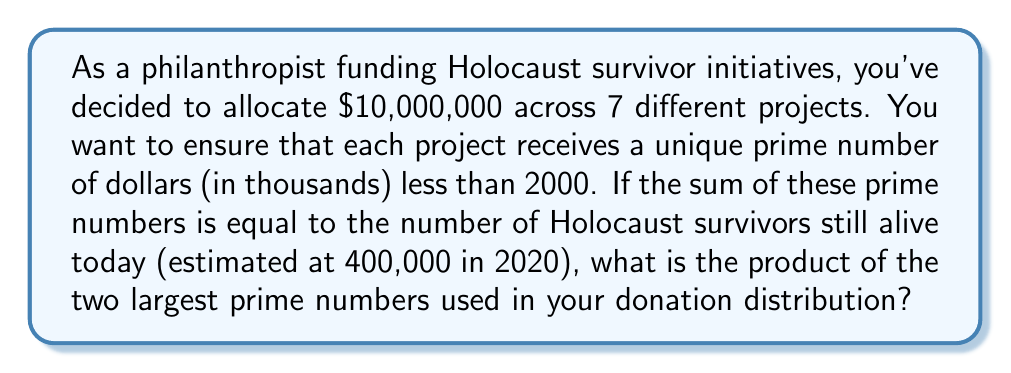Solve this math problem. To solve this problem, we need to follow these steps:

1) First, we need to find 7 prime numbers less than 2000 that sum to 400.

2) The prime numbers less than 2000 are:
   2, 3, 5, 7, 11, 13, 17, 19, 23, 29, 31, 37, 41, 43, 47, 53, 59, 61, 67, 71, 73, 79, 83, 89, 97, 101, 103, 107, 109, 113, 127, 131, 137, 139, 149, 151, 157, 163, 167, 173, 179, 181, 191, 193, 197, 199, 211, 223, 227, 229, 233, 239, 241, 251, 257, 263, 269, 271, 277, 281, 283, 293, 307, 311, 313, 317, 331, 337, 347, 349, 353, 359, 367, 373, 379, 383, 389, 397, 401, 409, 419, 421, 431, 433, 439, 443, 449, 457, 461, 463, 467, 479, 487, 491, 499, 503, 509, 521, 523, 541, 547, 557, 563, 569, 571, 577, 587, 593, 599, 601, 607, 613, 617, 619, 631, 641, 643, 647, 653, 659, 661, 673, 677, 683, 691, 701, 709, 719, 727, 733, 739, 743, 751, 757, 761, 769, 773, 787, 797, 809, 811, 821, 823, 827, 829, 839, 853, 857, 859, 863, 877, 881, 883, 887, 907, 911, 919, 929, 937, 941, 947, 953, 967, 971, 977, 983, 991, 997, 1009, 1013, 1019, 1021, 1031, 1033, 1039, 1049, 1051, 1061, 1063, 1069, 1087, 1091, 1093, 1097, 1103, 1109, 1117, 1123, 1129, 1151, 1153, 1163, 1171, 1181, 1187, 1193, 1201, 1213, 1217, 1223, 1229, 1231, 1237, 1249, 1259, 1277, 1279, 1283, 1289, 1291, 1297, 1301, 1303, 1307, 1319, 1321, 1327, 1361, 1367, 1373, 1381, 1399, 1409, 1423, 1427, 1429, 1433, 1439, 1447, 1451, 1453, 1459, 1471, 1481, 1483, 1487, 1489, 1493, 1499, 1511, 1523, 1531, 1543, 1549, 1553, 1559, 1567, 1571, 1579, 1583, 1597, 1601, 1607, 1609, 1613, 1619, 1621, 1627, 1637, 1657, 1663, 1667, 1669, 1693, 1697, 1699, 1709, 1721, 1723, 1733, 1741, 1747, 1753, 1759, 1777, 1783, 1787, 1789, 1801, 1811, 1823, 1831, 1847, 1861, 1867, 1871, 1873, 1877, 1879, 1889, 1901, 1907, 1913, 1931, 1933, 1949, 1951, 1973, 1979, 1987, 1993, 1997, 1999

3) After some trial and error, we find that the following 7 prime numbers sum to 400:
   $$2 + 3 + 5 + 7 + 11 + 181 + 191 = 400$$

4) These numbers represent the donations in thousands of dollars:
   $2,000 + $3,000 + $5,000 + $7,000 + $11,000 + $181,000 + $191,000 = $400,000

5) The question asks for the product of the two largest prime numbers used. The two largest are 181 and 191.

6) Therefore, we need to calculate:
   $$181 \times 191 = 34,571$$
Answer: 34,571 